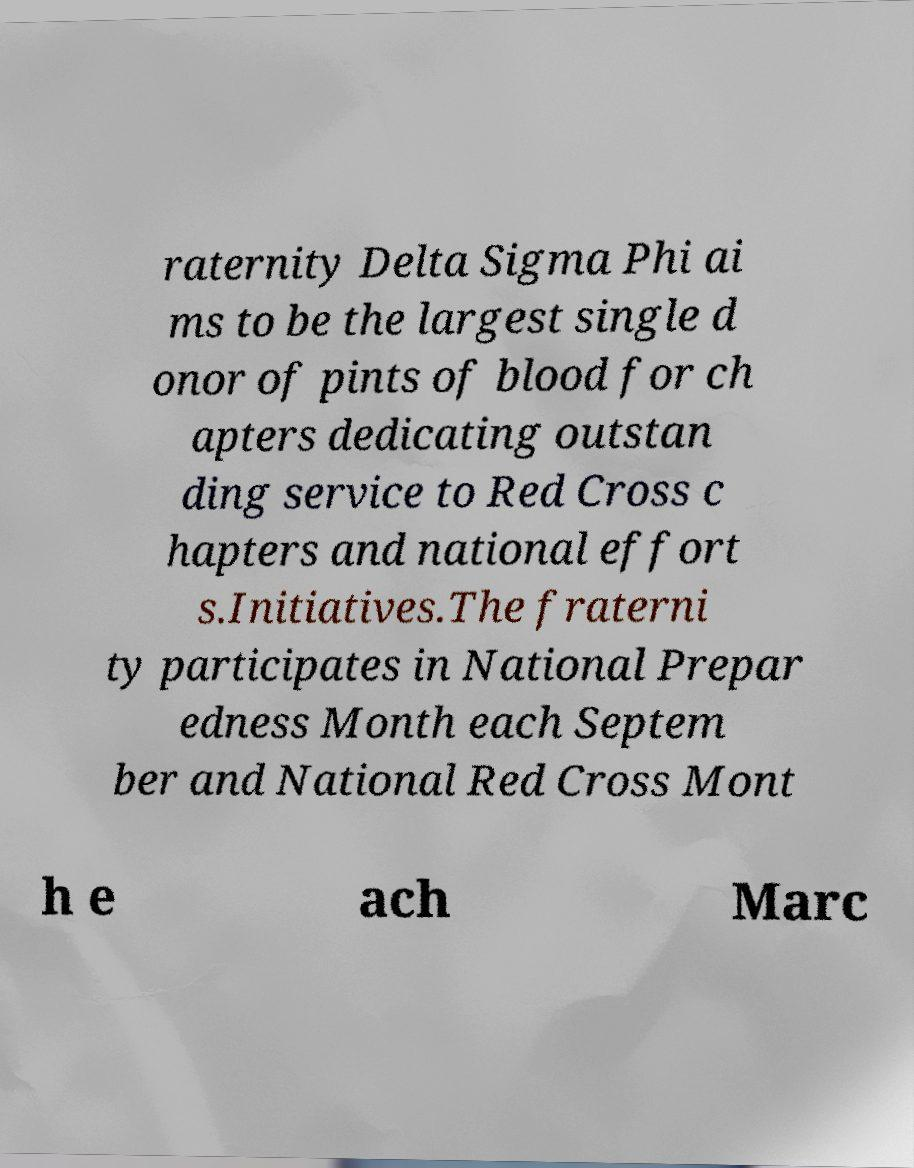Could you extract and type out the text from this image? raternity Delta Sigma Phi ai ms to be the largest single d onor of pints of blood for ch apters dedicating outstan ding service to Red Cross c hapters and national effort s.Initiatives.The fraterni ty participates in National Prepar edness Month each Septem ber and National Red Cross Mont h e ach Marc 